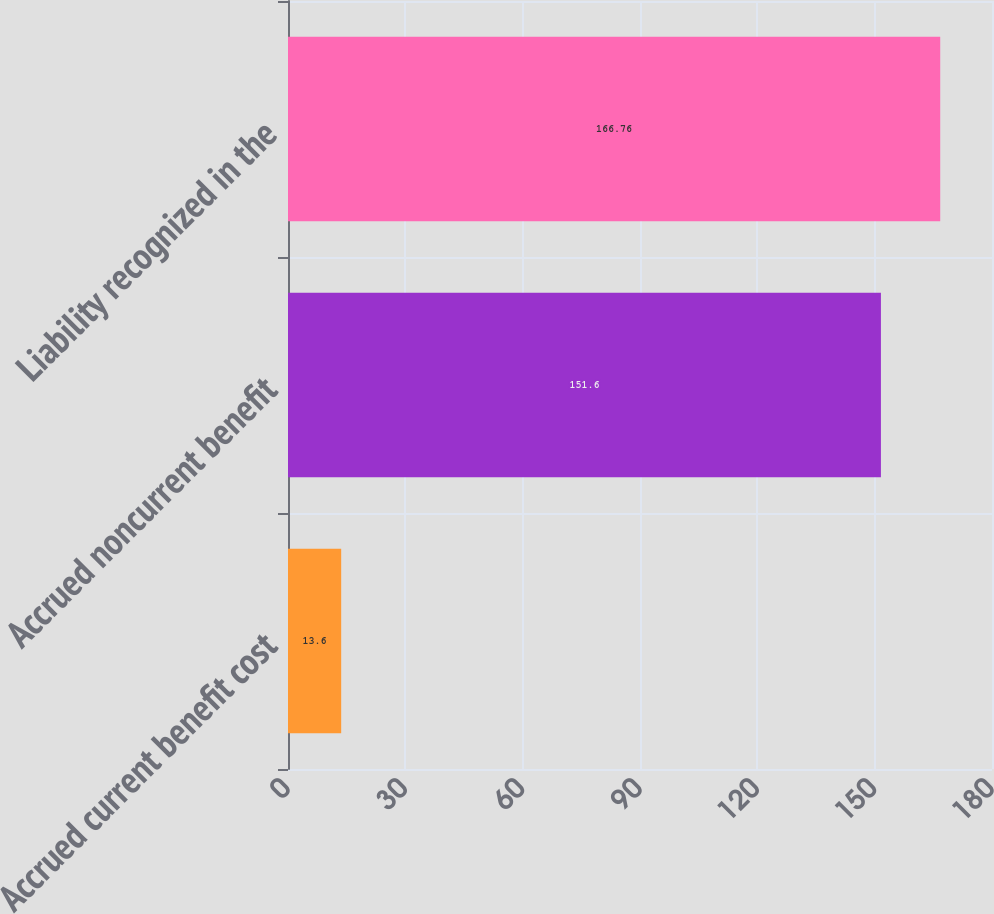Convert chart to OTSL. <chart><loc_0><loc_0><loc_500><loc_500><bar_chart><fcel>Accrued current benefit cost<fcel>Accrued noncurrent benefit<fcel>Liability recognized in the<nl><fcel>13.6<fcel>151.6<fcel>166.76<nl></chart> 